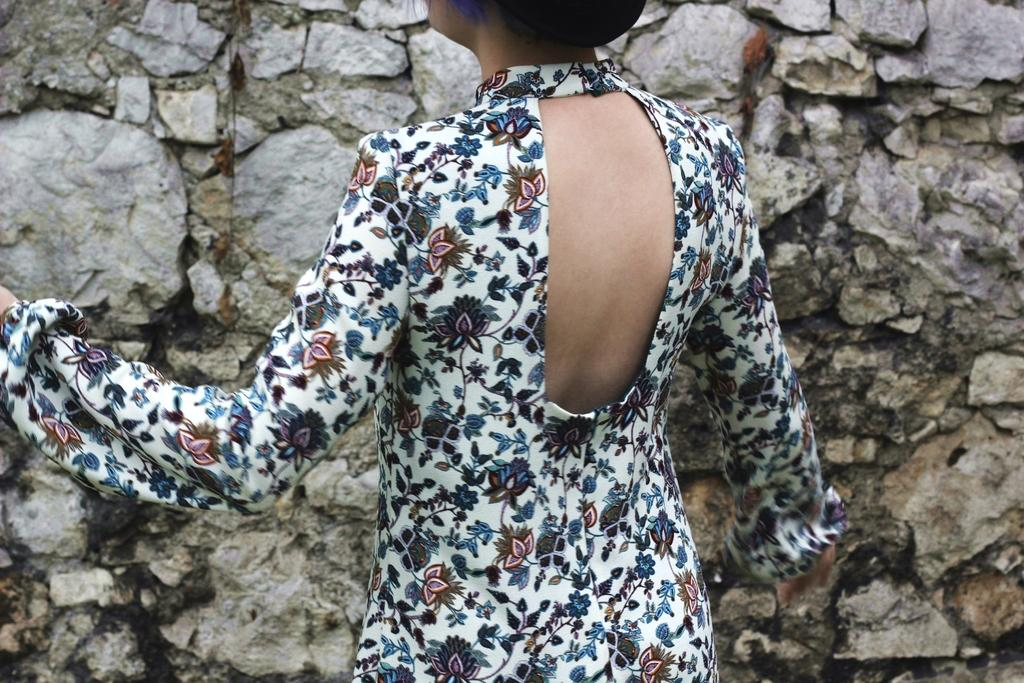Who is present in the image? There is a woman in the image. What is the woman wearing? The woman is wearing a white and blue dress. What can be seen behind the woman? There is a stone wall in front of the woman. How many dimes can be seen on the woman's dress in the image? There are no dimes visible on the woman's dress in the image. What is the temperature in the image? The temperature cannot be determined from the image alone, as it does not provide information about the weather or climate. 